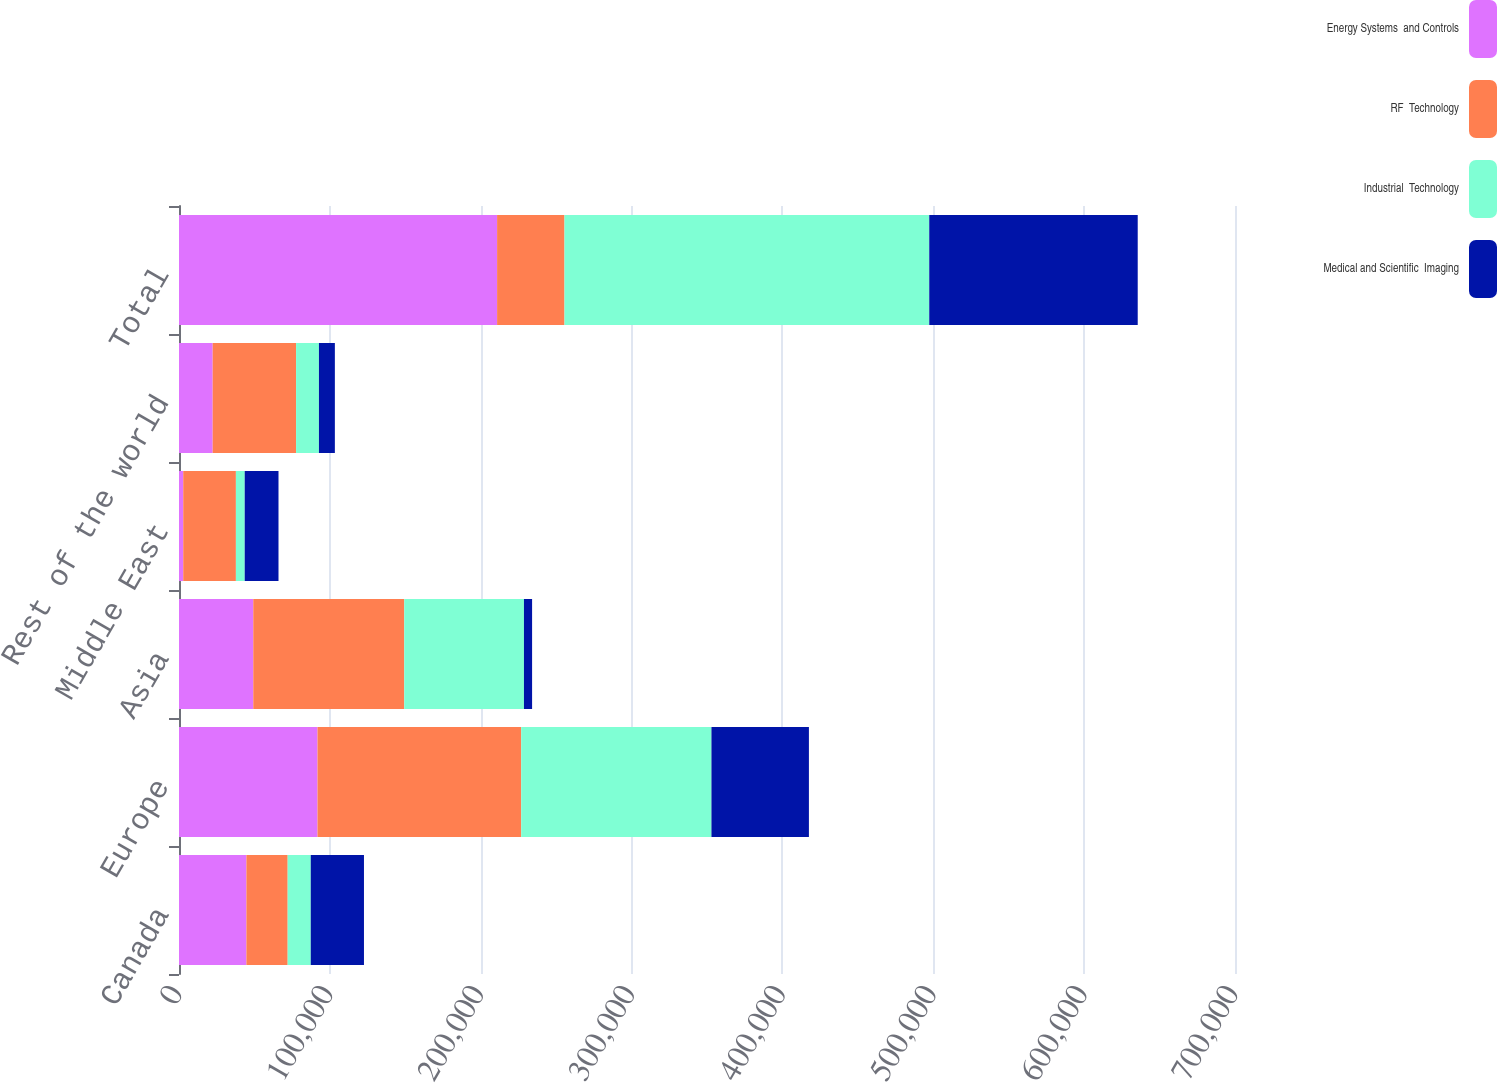Convert chart to OTSL. <chart><loc_0><loc_0><loc_500><loc_500><stacked_bar_chart><ecel><fcel>Canada<fcel>Europe<fcel>Asia<fcel>Middle East<fcel>Rest of the world<fcel>Total<nl><fcel>Energy Systems  and Controls<fcel>44678<fcel>91815<fcel>49232<fcel>2805<fcel>22328<fcel>210858<nl><fcel>RF  Technology<fcel>27360<fcel>135019<fcel>100094<fcel>34912<fcel>55280<fcel>44678<nl><fcel>Industrial  Technology<fcel>15306<fcel>126116<fcel>79343<fcel>5853<fcel>15169<fcel>241787<nl><fcel>Medical and Scientific  Imaging<fcel>35270<fcel>64605<fcel>5389<fcel>22387<fcel>10542<fcel>138193<nl></chart> 